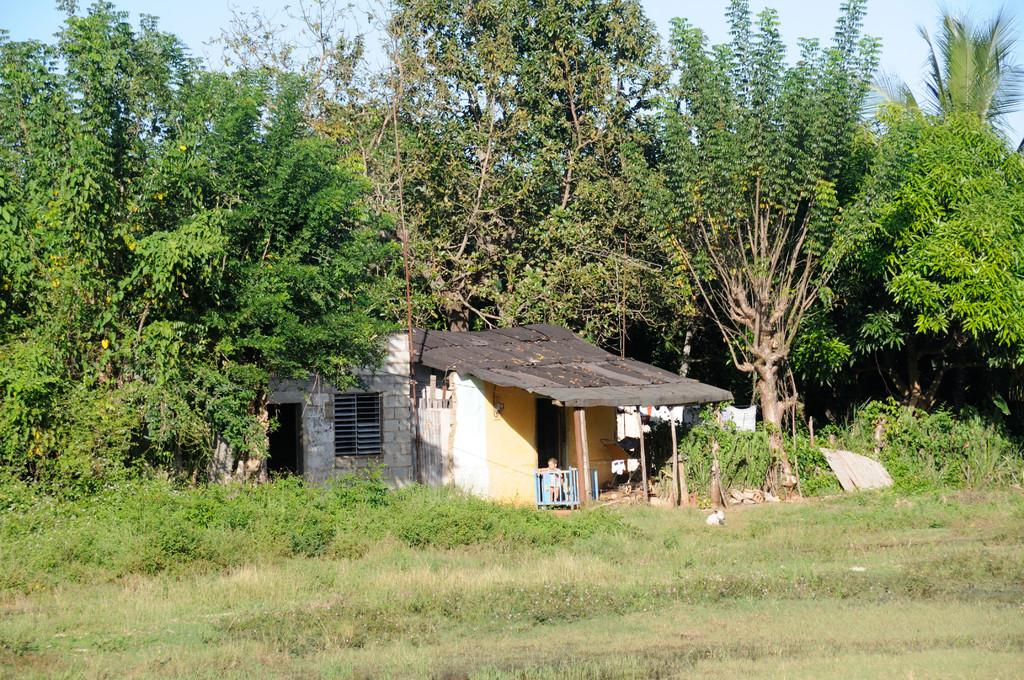What type of structure is present in the image? There is a small house in the image. What can be seen around the house? There is a lot of greenery around the house. What team is responsible for the existence of the small house in the image? There is no information about a team or any responsible party for the existence of the small house in the image. 